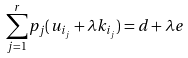Convert formula to latex. <formula><loc_0><loc_0><loc_500><loc_500>\sum _ { j = 1 } ^ { r } p _ { j } ( u _ { i _ { j } } + \lambda k _ { i _ { j } } ) = d + \lambda e</formula> 